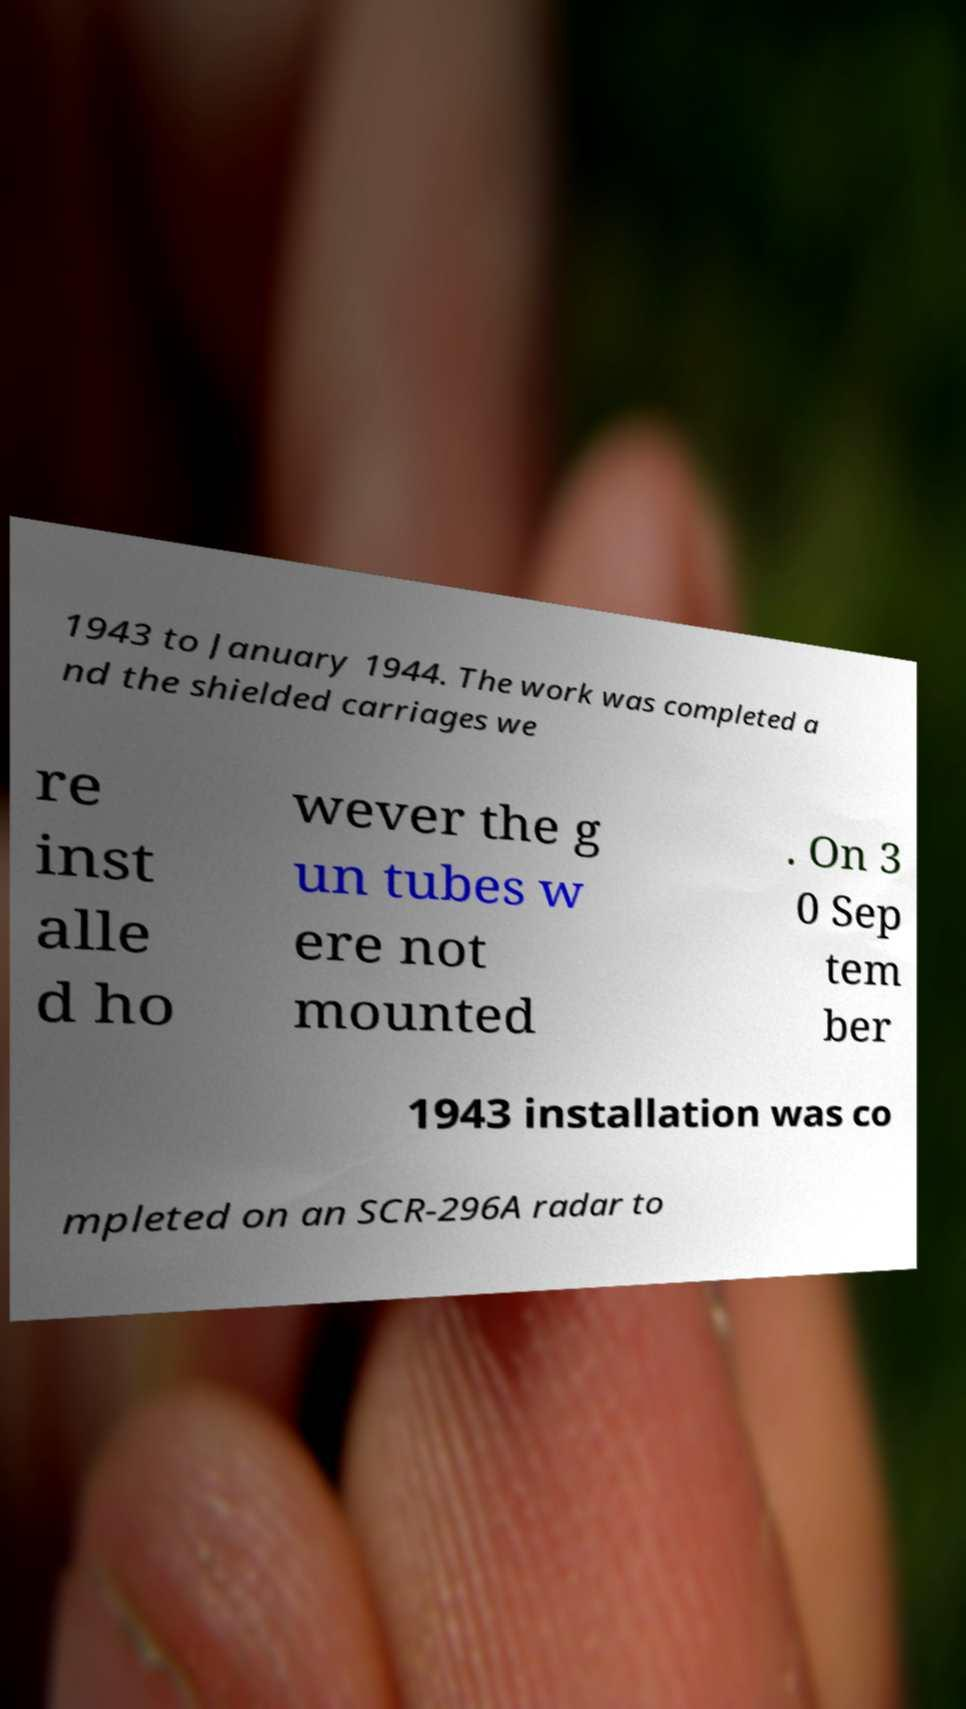Can you accurately transcribe the text from the provided image for me? 1943 to January 1944. The work was completed a nd the shielded carriages we re inst alle d ho wever the g un tubes w ere not mounted . On 3 0 Sep tem ber 1943 installation was co mpleted on an SCR-296A radar to 